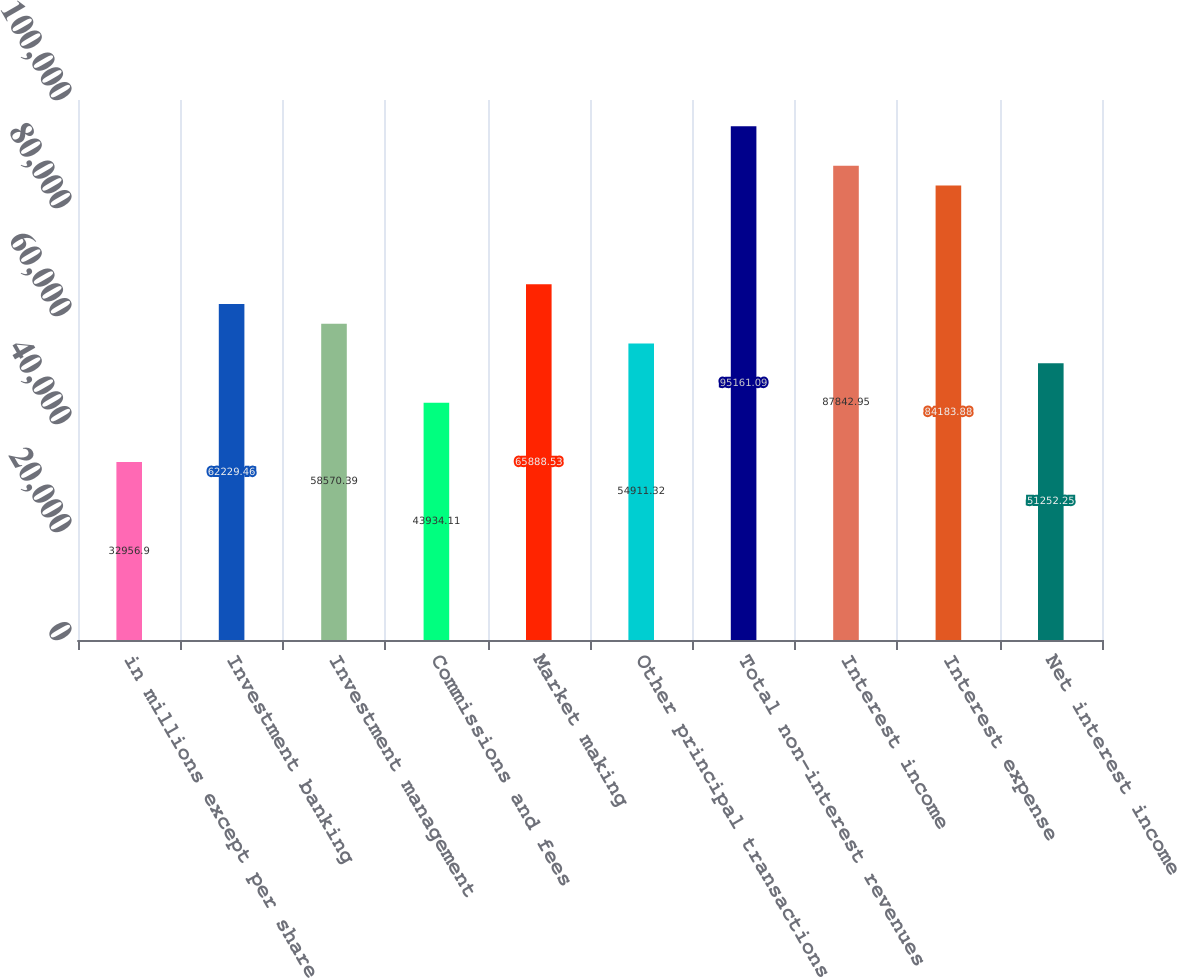Convert chart to OTSL. <chart><loc_0><loc_0><loc_500><loc_500><bar_chart><fcel>in millions except per share<fcel>Investment banking<fcel>Investment management<fcel>Commissions and fees<fcel>Market making<fcel>Other principal transactions<fcel>Total non-interest revenues<fcel>Interest income<fcel>Interest expense<fcel>Net interest income<nl><fcel>32956.9<fcel>62229.5<fcel>58570.4<fcel>43934.1<fcel>65888.5<fcel>54911.3<fcel>95161.1<fcel>87842.9<fcel>84183.9<fcel>51252.2<nl></chart> 